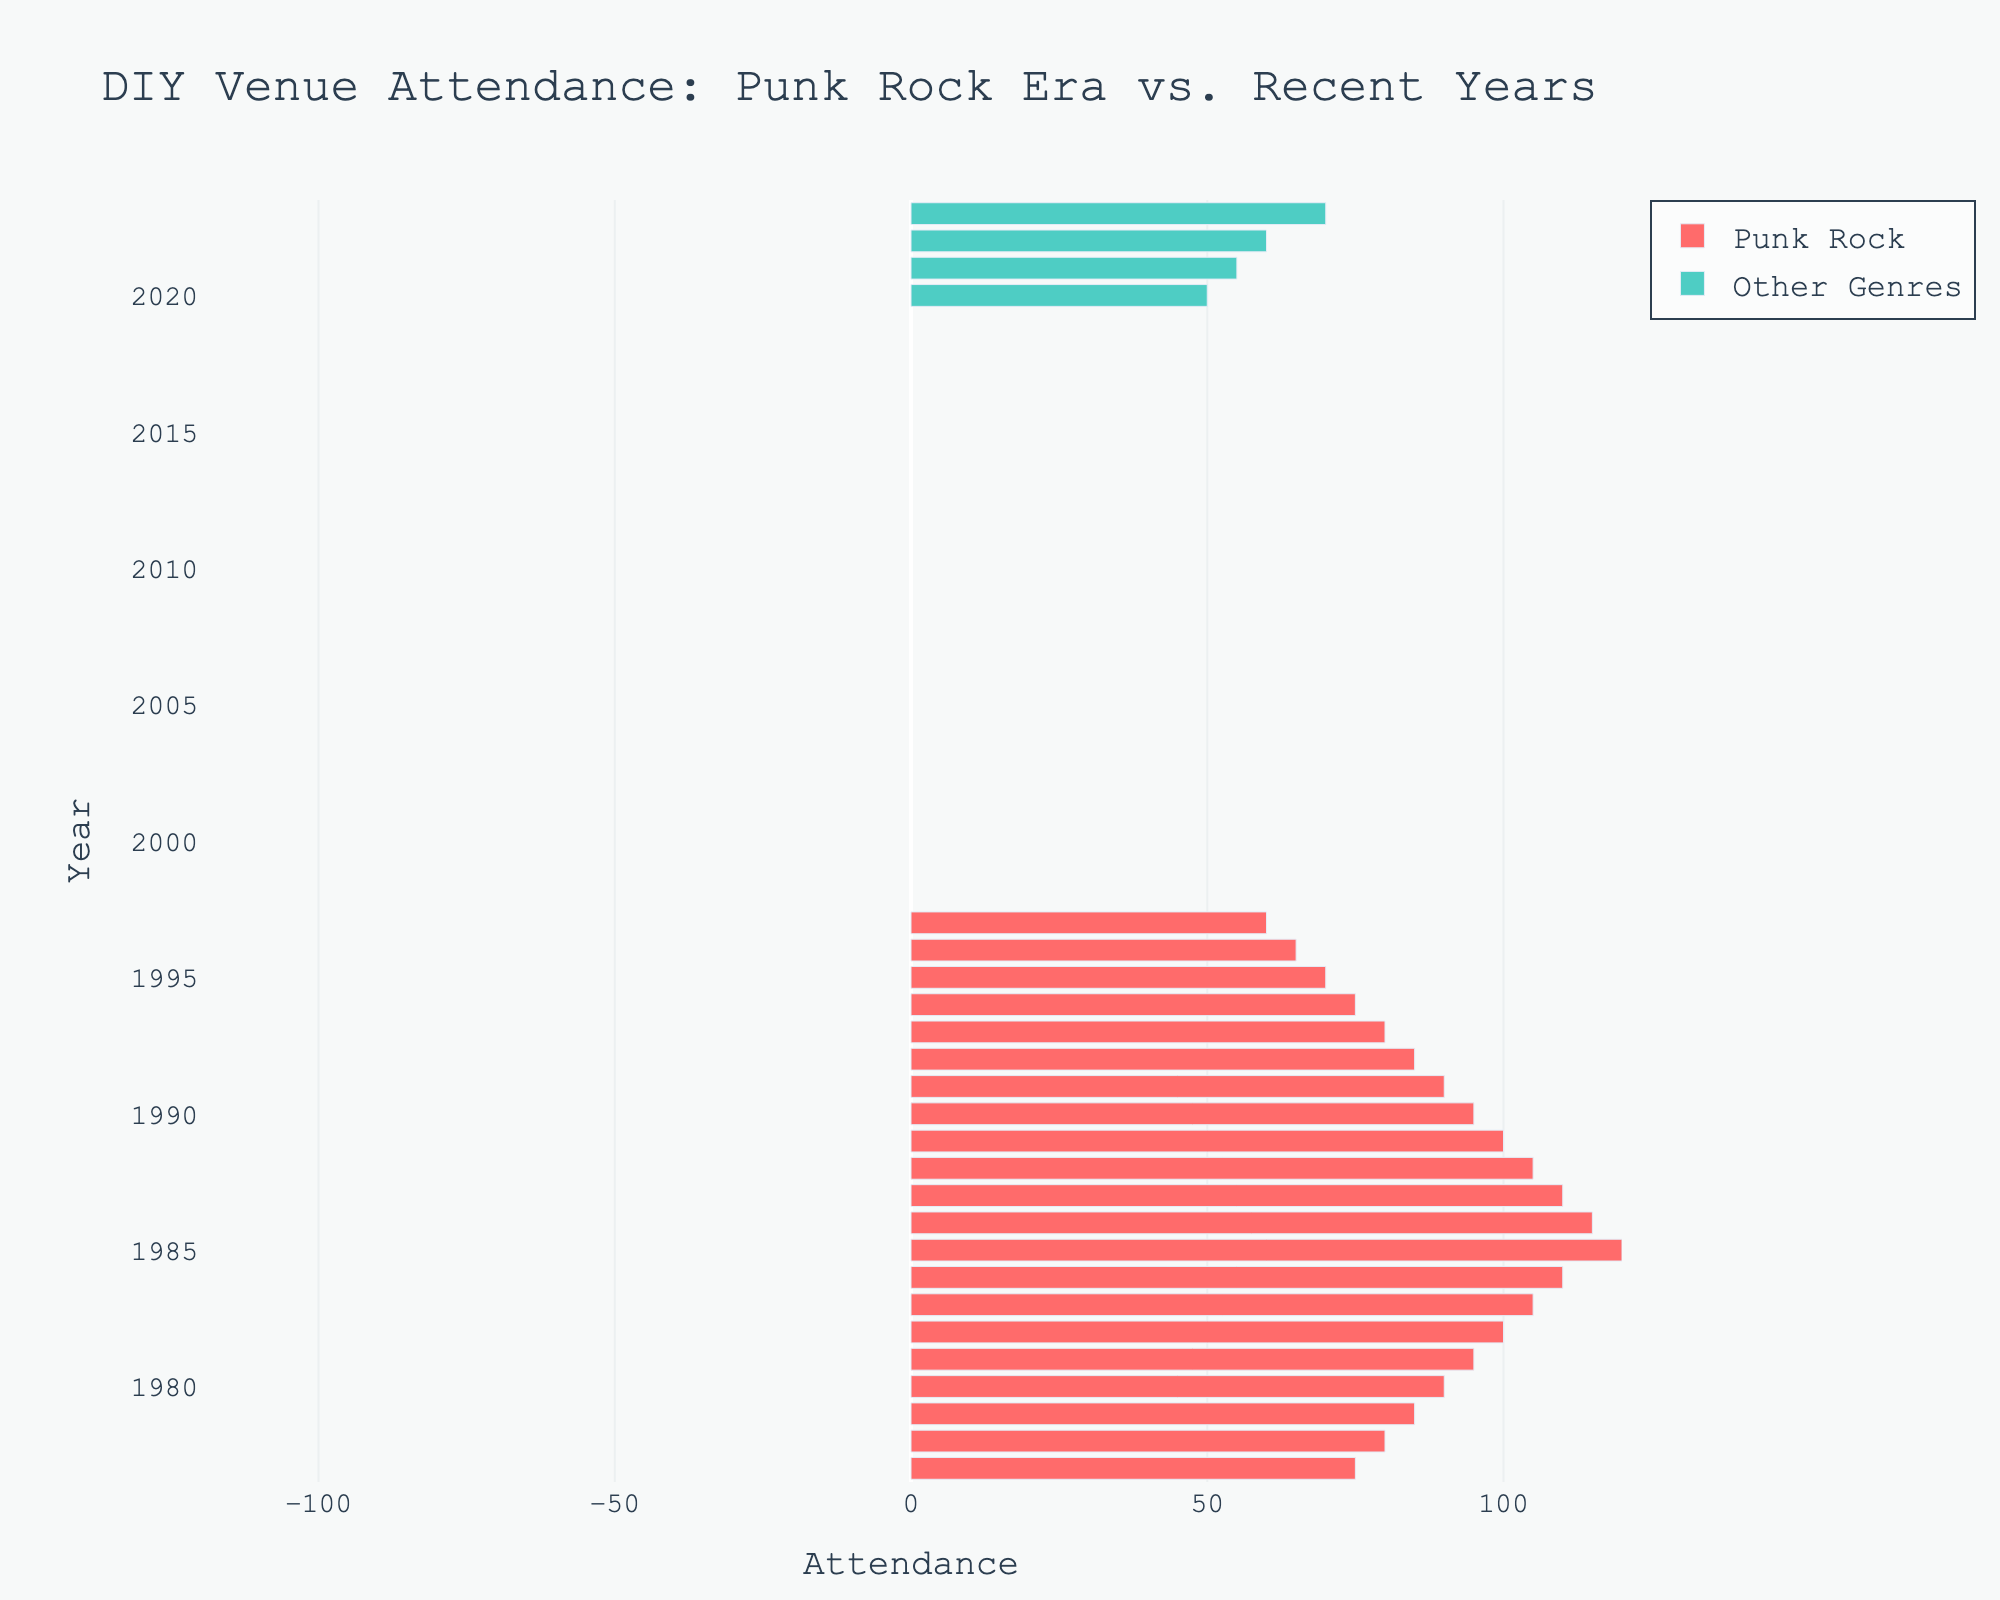What's the highest attendance for Punk Rock? By observing the longest red bar, we see that in 1985 the attendance for Punk Rock peaked at 120.
Answer: 120 How does the attendance of Other Genres in 2023 compare to Punk Rock in 1985? The green bar for Other Genres in 2023 has an attendance of 70, while the red bar for Punk Rock in 1985 has an attendance of 120. Punk Rock had a higher attendance.
Answer: Punk Rock had a higher attendance What was the average attendance for Punk Rock from 1977 to 1997? Sum the attendance values for Punk Rock from 1977 to 1997, which are: 75, 80, 85, 90, 95, 100, 105, 110, 120, 115, 110, 105, 100, 95, 90, 85, 80, 75, 70, 65, 60. The sum is 1815. There are 21 years, so the average is 1815 / 21 = 86.43
Answer: 86.43 In which year did Punk Rock attendance first decrease after a peak? Punk Rock attendance peaked in 1985 at 120 and then decreased in 1986 to 115.
Answer: 1986 What is the difference in attendance between the highest and lowest years for Punk Rock? The highest attendance for Punk Rock was 120 in 1985 and the lowest was 60 in 1997. The difference is 120 - 60 = 60.
Answer: 60 Which genre had a higher attendance in 2020? In 2020, Other Genres had an attendance of 50. Punk Rock is not shown for this year, so Other Genres had the higher attendance.
Answer: Other Genres How does the attendance trend for Punk Rock from 1977 to 1997 compare to other genres from 2020 to 2023? Punk Rock attendance from 1977 to 1997 increased initially, peaked in 1985, then steadily declined. Other genres from 2020 to 2023 show a steady increase.
Answer: Punk Rock peaked then declined, Other Genres increased steadily What was the median attendance for Punk Rock from 1977 to 1997? List the attendance values for Punk Rock from 1977 to 1997: 60, 65, 70, 75, 75, 80, 80, 85, 85, 90, 90, 95, 95, 100, 100, 105, 105, 110, 110, 115, 120. With 21 values, the median is the 11th value: 90.
Answer: 90 What is the percentage decrease in attendance for Punk Rock from its peak to its lowest point? The peak attendance was 120 in 1985, and the lowest point was 60 in 1997, a decrease of 120 - 60 = 60. The percentage decrease is (60 / 120) * 100 = 50%.
Answer: 50% Which year had the closest attendance figures between Punk Rock and Other Genres? By visual comparison, in 2023, Other Genres had an attendance of 70, which is closest to the attendance of 1977 for Punk Rock at 75. The difference is 5.
Answer: 2023 